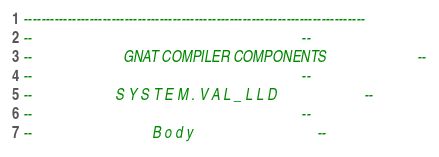<code> <loc_0><loc_0><loc_500><loc_500><_Ada_>------------------------------------------------------------------------------
--                                                                          --
--                         GNAT COMPILER COMPONENTS                         --
--                                                                          --
--                       S Y S T E M . V A L _ L L D                        --
--                                                                          --
--                                 B o d y                                  --</code> 